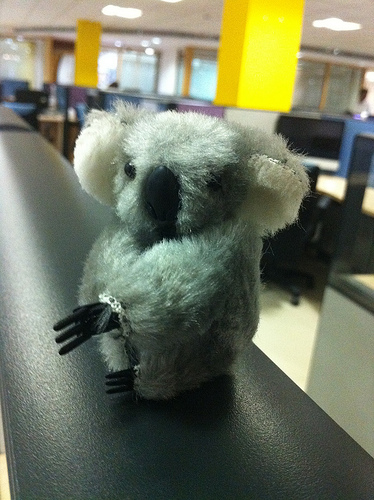<image>
Can you confirm if the toy is above the wall? Yes. The toy is positioned above the wall in the vertical space, higher up in the scene. Is there a ring on the koala? Yes. Looking at the image, I can see the ring is positioned on top of the koala, with the koala providing support. 